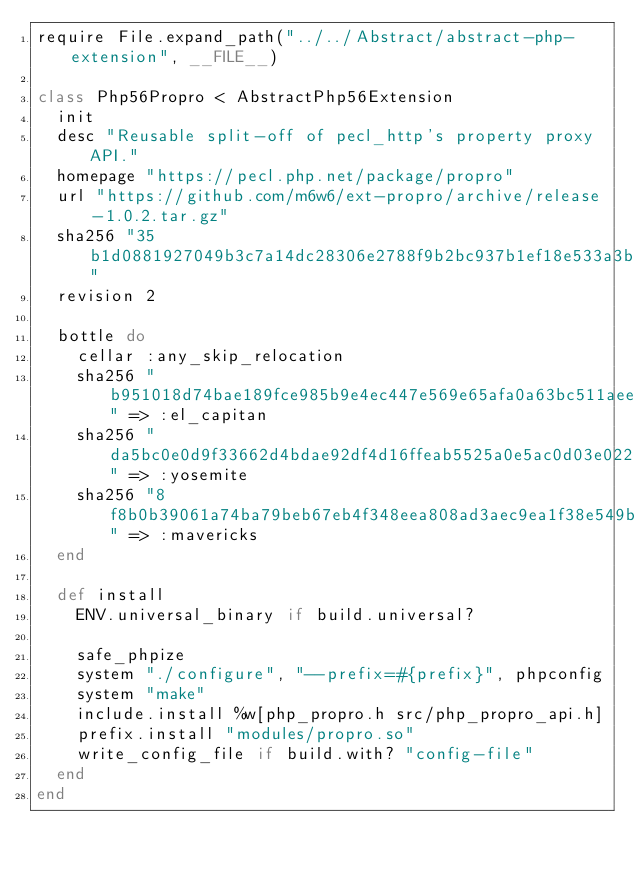Convert code to text. <code><loc_0><loc_0><loc_500><loc_500><_Ruby_>require File.expand_path("../../Abstract/abstract-php-extension", __FILE__)

class Php56Propro < AbstractPhp56Extension
  init
  desc "Reusable split-off of pecl_http's property proxy API."
  homepage "https://pecl.php.net/package/propro"
  url "https://github.com/m6w6/ext-propro/archive/release-1.0.2.tar.gz"
  sha256 "35b1d0881927049b3c7a14dc28306e2788f9b2bc937b1ef18e533a3bef8befce"
  revision 2

  bottle do
    cellar :any_skip_relocation
    sha256 "b951018d74bae189fce985b9e4ec447e569e65afa0a63bc511aeedeb498e084d" => :el_capitan
    sha256 "da5bc0e0d9f33662d4bdae92df4d16ffeab5525a0e5ac0d03e0224d89b2de7b4" => :yosemite
    sha256 "8f8b0b39061a74ba79beb67eb4f348eea808ad3aec9ea1f38e549bbd8e8e72e1" => :mavericks
  end

  def install
    ENV.universal_binary if build.universal?

    safe_phpize
    system "./configure", "--prefix=#{prefix}", phpconfig
    system "make"
    include.install %w[php_propro.h src/php_propro_api.h]
    prefix.install "modules/propro.so"
    write_config_file if build.with? "config-file"
  end
end
</code> 